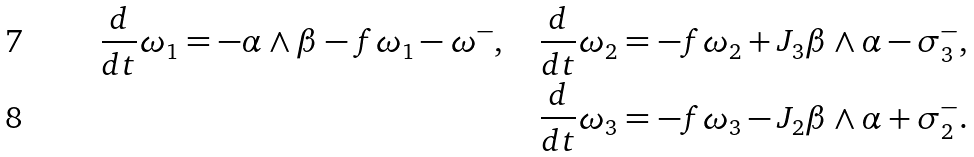<formula> <loc_0><loc_0><loc_500><loc_500>\frac { d } { d t } \omega _ { 1 } = - \alpha \wedge \beta - f \omega _ { 1 } - \omega ^ { - } , \quad \frac { d } { d t } \omega _ { 2 } = - f \omega _ { 2 } + J _ { 3 } \beta \wedge \alpha - \sigma _ { 3 } ^ { - } , \\ \frac { d } { d t } \omega _ { 3 } = - f \omega _ { 3 } - J _ { 2 } \beta \wedge \alpha + \sigma _ { 2 } ^ { - } .</formula> 